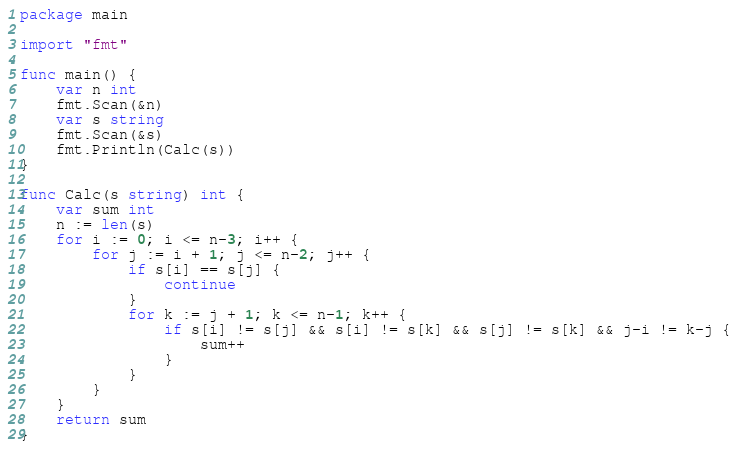Convert code to text. <code><loc_0><loc_0><loc_500><loc_500><_Go_>package main

import "fmt"

func main() {
	var n int
	fmt.Scan(&n)
	var s string
	fmt.Scan(&s)
	fmt.Println(Calc(s))
}

func Calc(s string) int {
	var sum int
	n := len(s)
	for i := 0; i <= n-3; i++ {
		for j := i + 1; j <= n-2; j++ {
			if s[i] == s[j] {
				continue
			}
			for k := j + 1; k <= n-1; k++ {
				if s[i] != s[j] && s[i] != s[k] && s[j] != s[k] && j-i != k-j {
					sum++
				}
			}
		}
	}
	return sum
}
</code> 